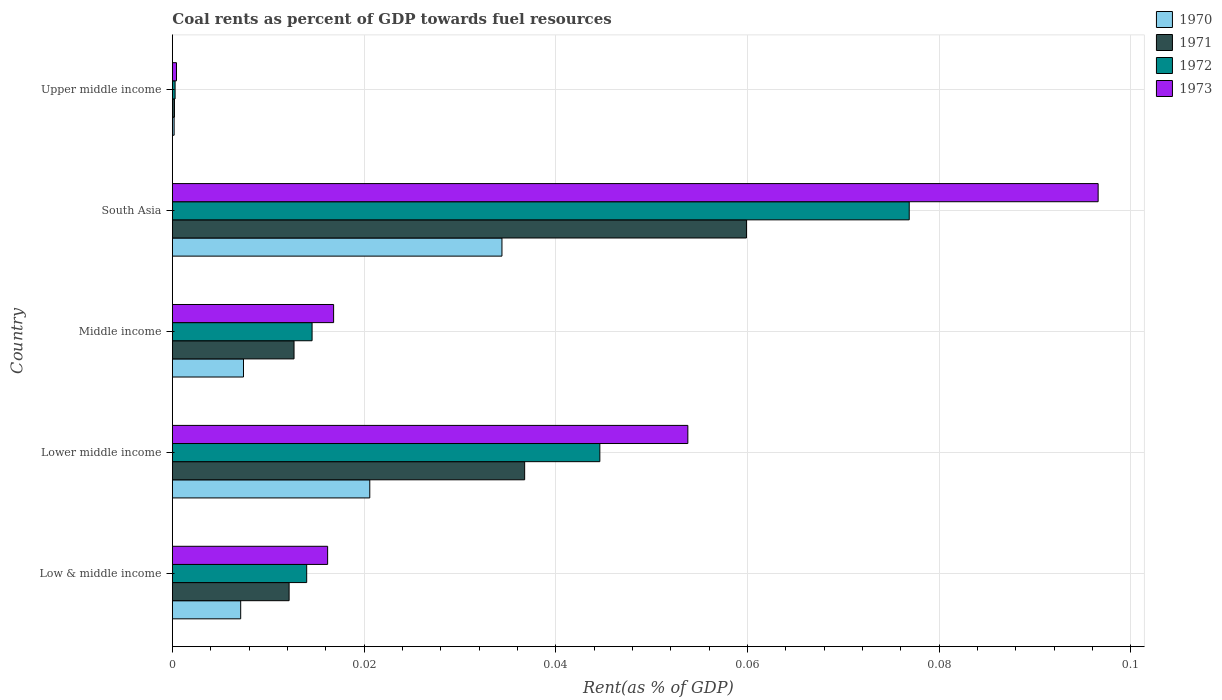How many groups of bars are there?
Your answer should be compact. 5. Are the number of bars on each tick of the Y-axis equal?
Provide a succinct answer. Yes. What is the label of the 5th group of bars from the top?
Provide a succinct answer. Low & middle income. What is the coal rent in 1970 in Upper middle income?
Your answer should be very brief. 0. Across all countries, what is the maximum coal rent in 1970?
Ensure brevity in your answer.  0.03. Across all countries, what is the minimum coal rent in 1970?
Make the answer very short. 0. In which country was the coal rent in 1970 minimum?
Make the answer very short. Upper middle income. What is the total coal rent in 1971 in the graph?
Offer a terse response. 0.12. What is the difference between the coal rent in 1971 in Lower middle income and that in Middle income?
Provide a succinct answer. 0.02. What is the difference between the coal rent in 1971 in South Asia and the coal rent in 1970 in Low & middle income?
Make the answer very short. 0.05. What is the average coal rent in 1970 per country?
Offer a very short reply. 0.01. What is the difference between the coal rent in 1972 and coal rent in 1971 in Low & middle income?
Offer a very short reply. 0. In how many countries, is the coal rent in 1970 greater than 0.044 %?
Ensure brevity in your answer.  0. What is the ratio of the coal rent in 1973 in Lower middle income to that in South Asia?
Give a very brief answer. 0.56. Is the coal rent in 1970 in Lower middle income less than that in Upper middle income?
Your response must be concise. No. What is the difference between the highest and the second highest coal rent in 1971?
Keep it short and to the point. 0.02. What is the difference between the highest and the lowest coal rent in 1973?
Ensure brevity in your answer.  0.1. Is the sum of the coal rent in 1971 in Lower middle income and South Asia greater than the maximum coal rent in 1970 across all countries?
Your answer should be very brief. Yes. Is it the case that in every country, the sum of the coal rent in 1972 and coal rent in 1971 is greater than the sum of coal rent in 1970 and coal rent in 1973?
Your response must be concise. No. What does the 1st bar from the bottom in Upper middle income represents?
Ensure brevity in your answer.  1970. Is it the case that in every country, the sum of the coal rent in 1973 and coal rent in 1971 is greater than the coal rent in 1970?
Provide a short and direct response. Yes. How many bars are there?
Keep it short and to the point. 20. Are all the bars in the graph horizontal?
Your response must be concise. Yes. What is the difference between two consecutive major ticks on the X-axis?
Provide a succinct answer. 0.02. Are the values on the major ticks of X-axis written in scientific E-notation?
Provide a short and direct response. No. What is the title of the graph?
Offer a terse response. Coal rents as percent of GDP towards fuel resources. What is the label or title of the X-axis?
Provide a succinct answer. Rent(as % of GDP). What is the Rent(as % of GDP) in 1970 in Low & middle income?
Keep it short and to the point. 0.01. What is the Rent(as % of GDP) in 1971 in Low & middle income?
Provide a succinct answer. 0.01. What is the Rent(as % of GDP) of 1972 in Low & middle income?
Ensure brevity in your answer.  0.01. What is the Rent(as % of GDP) of 1973 in Low & middle income?
Offer a very short reply. 0.02. What is the Rent(as % of GDP) of 1970 in Lower middle income?
Make the answer very short. 0.02. What is the Rent(as % of GDP) of 1971 in Lower middle income?
Give a very brief answer. 0.04. What is the Rent(as % of GDP) in 1972 in Lower middle income?
Your answer should be very brief. 0.04. What is the Rent(as % of GDP) in 1973 in Lower middle income?
Ensure brevity in your answer.  0.05. What is the Rent(as % of GDP) of 1970 in Middle income?
Your response must be concise. 0.01. What is the Rent(as % of GDP) in 1971 in Middle income?
Give a very brief answer. 0.01. What is the Rent(as % of GDP) of 1972 in Middle income?
Your response must be concise. 0.01. What is the Rent(as % of GDP) of 1973 in Middle income?
Keep it short and to the point. 0.02. What is the Rent(as % of GDP) of 1970 in South Asia?
Make the answer very short. 0.03. What is the Rent(as % of GDP) in 1971 in South Asia?
Your answer should be compact. 0.06. What is the Rent(as % of GDP) of 1972 in South Asia?
Keep it short and to the point. 0.08. What is the Rent(as % of GDP) in 1973 in South Asia?
Provide a short and direct response. 0.1. What is the Rent(as % of GDP) in 1970 in Upper middle income?
Make the answer very short. 0. What is the Rent(as % of GDP) of 1971 in Upper middle income?
Your answer should be compact. 0. What is the Rent(as % of GDP) of 1972 in Upper middle income?
Provide a short and direct response. 0. What is the Rent(as % of GDP) in 1973 in Upper middle income?
Give a very brief answer. 0. Across all countries, what is the maximum Rent(as % of GDP) of 1970?
Make the answer very short. 0.03. Across all countries, what is the maximum Rent(as % of GDP) of 1971?
Keep it short and to the point. 0.06. Across all countries, what is the maximum Rent(as % of GDP) of 1972?
Ensure brevity in your answer.  0.08. Across all countries, what is the maximum Rent(as % of GDP) of 1973?
Offer a very short reply. 0.1. Across all countries, what is the minimum Rent(as % of GDP) of 1970?
Your answer should be very brief. 0. Across all countries, what is the minimum Rent(as % of GDP) in 1971?
Ensure brevity in your answer.  0. Across all countries, what is the minimum Rent(as % of GDP) of 1972?
Your response must be concise. 0. Across all countries, what is the minimum Rent(as % of GDP) of 1973?
Your response must be concise. 0. What is the total Rent(as % of GDP) in 1970 in the graph?
Provide a short and direct response. 0.07. What is the total Rent(as % of GDP) in 1971 in the graph?
Give a very brief answer. 0.12. What is the total Rent(as % of GDP) of 1972 in the graph?
Give a very brief answer. 0.15. What is the total Rent(as % of GDP) of 1973 in the graph?
Ensure brevity in your answer.  0.18. What is the difference between the Rent(as % of GDP) of 1970 in Low & middle income and that in Lower middle income?
Make the answer very short. -0.01. What is the difference between the Rent(as % of GDP) in 1971 in Low & middle income and that in Lower middle income?
Provide a succinct answer. -0.02. What is the difference between the Rent(as % of GDP) in 1972 in Low & middle income and that in Lower middle income?
Provide a succinct answer. -0.03. What is the difference between the Rent(as % of GDP) of 1973 in Low & middle income and that in Lower middle income?
Keep it short and to the point. -0.04. What is the difference between the Rent(as % of GDP) of 1970 in Low & middle income and that in Middle income?
Your answer should be very brief. -0. What is the difference between the Rent(as % of GDP) of 1971 in Low & middle income and that in Middle income?
Offer a terse response. -0. What is the difference between the Rent(as % of GDP) of 1972 in Low & middle income and that in Middle income?
Ensure brevity in your answer.  -0. What is the difference between the Rent(as % of GDP) of 1973 in Low & middle income and that in Middle income?
Your answer should be compact. -0. What is the difference between the Rent(as % of GDP) of 1970 in Low & middle income and that in South Asia?
Ensure brevity in your answer.  -0.03. What is the difference between the Rent(as % of GDP) of 1971 in Low & middle income and that in South Asia?
Your answer should be very brief. -0.05. What is the difference between the Rent(as % of GDP) in 1972 in Low & middle income and that in South Asia?
Keep it short and to the point. -0.06. What is the difference between the Rent(as % of GDP) in 1973 in Low & middle income and that in South Asia?
Ensure brevity in your answer.  -0.08. What is the difference between the Rent(as % of GDP) of 1970 in Low & middle income and that in Upper middle income?
Provide a short and direct response. 0.01. What is the difference between the Rent(as % of GDP) in 1971 in Low & middle income and that in Upper middle income?
Your response must be concise. 0.01. What is the difference between the Rent(as % of GDP) of 1972 in Low & middle income and that in Upper middle income?
Give a very brief answer. 0.01. What is the difference between the Rent(as % of GDP) of 1973 in Low & middle income and that in Upper middle income?
Provide a short and direct response. 0.02. What is the difference between the Rent(as % of GDP) in 1970 in Lower middle income and that in Middle income?
Your response must be concise. 0.01. What is the difference between the Rent(as % of GDP) of 1971 in Lower middle income and that in Middle income?
Your response must be concise. 0.02. What is the difference between the Rent(as % of GDP) of 1972 in Lower middle income and that in Middle income?
Keep it short and to the point. 0.03. What is the difference between the Rent(as % of GDP) of 1973 in Lower middle income and that in Middle income?
Provide a succinct answer. 0.04. What is the difference between the Rent(as % of GDP) of 1970 in Lower middle income and that in South Asia?
Give a very brief answer. -0.01. What is the difference between the Rent(as % of GDP) of 1971 in Lower middle income and that in South Asia?
Make the answer very short. -0.02. What is the difference between the Rent(as % of GDP) of 1972 in Lower middle income and that in South Asia?
Make the answer very short. -0.03. What is the difference between the Rent(as % of GDP) of 1973 in Lower middle income and that in South Asia?
Ensure brevity in your answer.  -0.04. What is the difference between the Rent(as % of GDP) in 1970 in Lower middle income and that in Upper middle income?
Give a very brief answer. 0.02. What is the difference between the Rent(as % of GDP) in 1971 in Lower middle income and that in Upper middle income?
Offer a terse response. 0.04. What is the difference between the Rent(as % of GDP) of 1972 in Lower middle income and that in Upper middle income?
Give a very brief answer. 0.04. What is the difference between the Rent(as % of GDP) in 1973 in Lower middle income and that in Upper middle income?
Offer a very short reply. 0.05. What is the difference between the Rent(as % of GDP) in 1970 in Middle income and that in South Asia?
Ensure brevity in your answer.  -0.03. What is the difference between the Rent(as % of GDP) in 1971 in Middle income and that in South Asia?
Provide a short and direct response. -0.05. What is the difference between the Rent(as % of GDP) of 1972 in Middle income and that in South Asia?
Give a very brief answer. -0.06. What is the difference between the Rent(as % of GDP) in 1973 in Middle income and that in South Asia?
Your answer should be compact. -0.08. What is the difference between the Rent(as % of GDP) of 1970 in Middle income and that in Upper middle income?
Make the answer very short. 0.01. What is the difference between the Rent(as % of GDP) in 1971 in Middle income and that in Upper middle income?
Ensure brevity in your answer.  0.01. What is the difference between the Rent(as % of GDP) in 1972 in Middle income and that in Upper middle income?
Your response must be concise. 0.01. What is the difference between the Rent(as % of GDP) in 1973 in Middle income and that in Upper middle income?
Your response must be concise. 0.02. What is the difference between the Rent(as % of GDP) of 1970 in South Asia and that in Upper middle income?
Provide a short and direct response. 0.03. What is the difference between the Rent(as % of GDP) of 1971 in South Asia and that in Upper middle income?
Make the answer very short. 0.06. What is the difference between the Rent(as % of GDP) in 1972 in South Asia and that in Upper middle income?
Your response must be concise. 0.08. What is the difference between the Rent(as % of GDP) of 1973 in South Asia and that in Upper middle income?
Your answer should be very brief. 0.1. What is the difference between the Rent(as % of GDP) of 1970 in Low & middle income and the Rent(as % of GDP) of 1971 in Lower middle income?
Offer a terse response. -0.03. What is the difference between the Rent(as % of GDP) in 1970 in Low & middle income and the Rent(as % of GDP) in 1972 in Lower middle income?
Your answer should be very brief. -0.04. What is the difference between the Rent(as % of GDP) in 1970 in Low & middle income and the Rent(as % of GDP) in 1973 in Lower middle income?
Keep it short and to the point. -0.05. What is the difference between the Rent(as % of GDP) in 1971 in Low & middle income and the Rent(as % of GDP) in 1972 in Lower middle income?
Your answer should be very brief. -0.03. What is the difference between the Rent(as % of GDP) in 1971 in Low & middle income and the Rent(as % of GDP) in 1973 in Lower middle income?
Offer a terse response. -0.04. What is the difference between the Rent(as % of GDP) in 1972 in Low & middle income and the Rent(as % of GDP) in 1973 in Lower middle income?
Make the answer very short. -0.04. What is the difference between the Rent(as % of GDP) in 1970 in Low & middle income and the Rent(as % of GDP) in 1971 in Middle income?
Give a very brief answer. -0.01. What is the difference between the Rent(as % of GDP) of 1970 in Low & middle income and the Rent(as % of GDP) of 1972 in Middle income?
Your answer should be very brief. -0.01. What is the difference between the Rent(as % of GDP) of 1970 in Low & middle income and the Rent(as % of GDP) of 1973 in Middle income?
Your response must be concise. -0.01. What is the difference between the Rent(as % of GDP) in 1971 in Low & middle income and the Rent(as % of GDP) in 1972 in Middle income?
Ensure brevity in your answer.  -0. What is the difference between the Rent(as % of GDP) in 1971 in Low & middle income and the Rent(as % of GDP) in 1973 in Middle income?
Give a very brief answer. -0. What is the difference between the Rent(as % of GDP) of 1972 in Low & middle income and the Rent(as % of GDP) of 1973 in Middle income?
Offer a very short reply. -0. What is the difference between the Rent(as % of GDP) in 1970 in Low & middle income and the Rent(as % of GDP) in 1971 in South Asia?
Provide a succinct answer. -0.05. What is the difference between the Rent(as % of GDP) of 1970 in Low & middle income and the Rent(as % of GDP) of 1972 in South Asia?
Make the answer very short. -0.07. What is the difference between the Rent(as % of GDP) in 1970 in Low & middle income and the Rent(as % of GDP) in 1973 in South Asia?
Offer a very short reply. -0.09. What is the difference between the Rent(as % of GDP) of 1971 in Low & middle income and the Rent(as % of GDP) of 1972 in South Asia?
Your response must be concise. -0.06. What is the difference between the Rent(as % of GDP) of 1971 in Low & middle income and the Rent(as % of GDP) of 1973 in South Asia?
Your answer should be compact. -0.08. What is the difference between the Rent(as % of GDP) in 1972 in Low & middle income and the Rent(as % of GDP) in 1973 in South Asia?
Your answer should be compact. -0.08. What is the difference between the Rent(as % of GDP) of 1970 in Low & middle income and the Rent(as % of GDP) of 1971 in Upper middle income?
Make the answer very short. 0.01. What is the difference between the Rent(as % of GDP) of 1970 in Low & middle income and the Rent(as % of GDP) of 1972 in Upper middle income?
Make the answer very short. 0.01. What is the difference between the Rent(as % of GDP) in 1970 in Low & middle income and the Rent(as % of GDP) in 1973 in Upper middle income?
Make the answer very short. 0.01. What is the difference between the Rent(as % of GDP) in 1971 in Low & middle income and the Rent(as % of GDP) in 1972 in Upper middle income?
Ensure brevity in your answer.  0.01. What is the difference between the Rent(as % of GDP) of 1971 in Low & middle income and the Rent(as % of GDP) of 1973 in Upper middle income?
Your answer should be very brief. 0.01. What is the difference between the Rent(as % of GDP) of 1972 in Low & middle income and the Rent(as % of GDP) of 1973 in Upper middle income?
Provide a short and direct response. 0.01. What is the difference between the Rent(as % of GDP) in 1970 in Lower middle income and the Rent(as % of GDP) in 1971 in Middle income?
Keep it short and to the point. 0.01. What is the difference between the Rent(as % of GDP) of 1970 in Lower middle income and the Rent(as % of GDP) of 1972 in Middle income?
Keep it short and to the point. 0.01. What is the difference between the Rent(as % of GDP) of 1970 in Lower middle income and the Rent(as % of GDP) of 1973 in Middle income?
Your answer should be very brief. 0. What is the difference between the Rent(as % of GDP) of 1971 in Lower middle income and the Rent(as % of GDP) of 1972 in Middle income?
Ensure brevity in your answer.  0.02. What is the difference between the Rent(as % of GDP) in 1971 in Lower middle income and the Rent(as % of GDP) in 1973 in Middle income?
Your answer should be very brief. 0.02. What is the difference between the Rent(as % of GDP) of 1972 in Lower middle income and the Rent(as % of GDP) of 1973 in Middle income?
Make the answer very short. 0.03. What is the difference between the Rent(as % of GDP) of 1970 in Lower middle income and the Rent(as % of GDP) of 1971 in South Asia?
Ensure brevity in your answer.  -0.04. What is the difference between the Rent(as % of GDP) in 1970 in Lower middle income and the Rent(as % of GDP) in 1972 in South Asia?
Provide a succinct answer. -0.06. What is the difference between the Rent(as % of GDP) of 1970 in Lower middle income and the Rent(as % of GDP) of 1973 in South Asia?
Your answer should be very brief. -0.08. What is the difference between the Rent(as % of GDP) of 1971 in Lower middle income and the Rent(as % of GDP) of 1972 in South Asia?
Your answer should be compact. -0.04. What is the difference between the Rent(as % of GDP) of 1971 in Lower middle income and the Rent(as % of GDP) of 1973 in South Asia?
Make the answer very short. -0.06. What is the difference between the Rent(as % of GDP) in 1972 in Lower middle income and the Rent(as % of GDP) in 1973 in South Asia?
Your answer should be very brief. -0.05. What is the difference between the Rent(as % of GDP) in 1970 in Lower middle income and the Rent(as % of GDP) in 1971 in Upper middle income?
Ensure brevity in your answer.  0.02. What is the difference between the Rent(as % of GDP) in 1970 in Lower middle income and the Rent(as % of GDP) in 1972 in Upper middle income?
Ensure brevity in your answer.  0.02. What is the difference between the Rent(as % of GDP) in 1970 in Lower middle income and the Rent(as % of GDP) in 1973 in Upper middle income?
Offer a very short reply. 0.02. What is the difference between the Rent(as % of GDP) in 1971 in Lower middle income and the Rent(as % of GDP) in 1972 in Upper middle income?
Give a very brief answer. 0.04. What is the difference between the Rent(as % of GDP) in 1971 in Lower middle income and the Rent(as % of GDP) in 1973 in Upper middle income?
Your response must be concise. 0.04. What is the difference between the Rent(as % of GDP) of 1972 in Lower middle income and the Rent(as % of GDP) of 1973 in Upper middle income?
Ensure brevity in your answer.  0.04. What is the difference between the Rent(as % of GDP) of 1970 in Middle income and the Rent(as % of GDP) of 1971 in South Asia?
Offer a very short reply. -0.05. What is the difference between the Rent(as % of GDP) in 1970 in Middle income and the Rent(as % of GDP) in 1972 in South Asia?
Your answer should be very brief. -0.07. What is the difference between the Rent(as % of GDP) in 1970 in Middle income and the Rent(as % of GDP) in 1973 in South Asia?
Offer a very short reply. -0.09. What is the difference between the Rent(as % of GDP) of 1971 in Middle income and the Rent(as % of GDP) of 1972 in South Asia?
Give a very brief answer. -0.06. What is the difference between the Rent(as % of GDP) of 1971 in Middle income and the Rent(as % of GDP) of 1973 in South Asia?
Provide a succinct answer. -0.08. What is the difference between the Rent(as % of GDP) in 1972 in Middle income and the Rent(as % of GDP) in 1973 in South Asia?
Your answer should be compact. -0.08. What is the difference between the Rent(as % of GDP) of 1970 in Middle income and the Rent(as % of GDP) of 1971 in Upper middle income?
Offer a very short reply. 0.01. What is the difference between the Rent(as % of GDP) in 1970 in Middle income and the Rent(as % of GDP) in 1972 in Upper middle income?
Offer a terse response. 0.01. What is the difference between the Rent(as % of GDP) in 1970 in Middle income and the Rent(as % of GDP) in 1973 in Upper middle income?
Make the answer very short. 0.01. What is the difference between the Rent(as % of GDP) of 1971 in Middle income and the Rent(as % of GDP) of 1972 in Upper middle income?
Offer a terse response. 0.01. What is the difference between the Rent(as % of GDP) in 1971 in Middle income and the Rent(as % of GDP) in 1973 in Upper middle income?
Your response must be concise. 0.01. What is the difference between the Rent(as % of GDP) of 1972 in Middle income and the Rent(as % of GDP) of 1973 in Upper middle income?
Your answer should be compact. 0.01. What is the difference between the Rent(as % of GDP) in 1970 in South Asia and the Rent(as % of GDP) in 1971 in Upper middle income?
Your answer should be compact. 0.03. What is the difference between the Rent(as % of GDP) of 1970 in South Asia and the Rent(as % of GDP) of 1972 in Upper middle income?
Provide a short and direct response. 0.03. What is the difference between the Rent(as % of GDP) of 1970 in South Asia and the Rent(as % of GDP) of 1973 in Upper middle income?
Keep it short and to the point. 0.03. What is the difference between the Rent(as % of GDP) of 1971 in South Asia and the Rent(as % of GDP) of 1972 in Upper middle income?
Provide a short and direct response. 0.06. What is the difference between the Rent(as % of GDP) in 1971 in South Asia and the Rent(as % of GDP) in 1973 in Upper middle income?
Offer a very short reply. 0.06. What is the difference between the Rent(as % of GDP) in 1972 in South Asia and the Rent(as % of GDP) in 1973 in Upper middle income?
Ensure brevity in your answer.  0.08. What is the average Rent(as % of GDP) in 1970 per country?
Your answer should be very brief. 0.01. What is the average Rent(as % of GDP) of 1971 per country?
Make the answer very short. 0.02. What is the average Rent(as % of GDP) in 1972 per country?
Provide a succinct answer. 0.03. What is the average Rent(as % of GDP) of 1973 per country?
Your response must be concise. 0.04. What is the difference between the Rent(as % of GDP) of 1970 and Rent(as % of GDP) of 1971 in Low & middle income?
Your answer should be very brief. -0.01. What is the difference between the Rent(as % of GDP) of 1970 and Rent(as % of GDP) of 1972 in Low & middle income?
Ensure brevity in your answer.  -0.01. What is the difference between the Rent(as % of GDP) of 1970 and Rent(as % of GDP) of 1973 in Low & middle income?
Provide a short and direct response. -0.01. What is the difference between the Rent(as % of GDP) in 1971 and Rent(as % of GDP) in 1972 in Low & middle income?
Provide a succinct answer. -0. What is the difference between the Rent(as % of GDP) in 1971 and Rent(as % of GDP) in 1973 in Low & middle income?
Ensure brevity in your answer.  -0. What is the difference between the Rent(as % of GDP) of 1972 and Rent(as % of GDP) of 1973 in Low & middle income?
Your answer should be compact. -0. What is the difference between the Rent(as % of GDP) in 1970 and Rent(as % of GDP) in 1971 in Lower middle income?
Keep it short and to the point. -0.02. What is the difference between the Rent(as % of GDP) of 1970 and Rent(as % of GDP) of 1972 in Lower middle income?
Give a very brief answer. -0.02. What is the difference between the Rent(as % of GDP) of 1970 and Rent(as % of GDP) of 1973 in Lower middle income?
Your response must be concise. -0.03. What is the difference between the Rent(as % of GDP) in 1971 and Rent(as % of GDP) in 1972 in Lower middle income?
Provide a short and direct response. -0.01. What is the difference between the Rent(as % of GDP) of 1971 and Rent(as % of GDP) of 1973 in Lower middle income?
Give a very brief answer. -0.02. What is the difference between the Rent(as % of GDP) in 1972 and Rent(as % of GDP) in 1973 in Lower middle income?
Your answer should be very brief. -0.01. What is the difference between the Rent(as % of GDP) of 1970 and Rent(as % of GDP) of 1971 in Middle income?
Make the answer very short. -0.01. What is the difference between the Rent(as % of GDP) of 1970 and Rent(as % of GDP) of 1972 in Middle income?
Provide a short and direct response. -0.01. What is the difference between the Rent(as % of GDP) of 1970 and Rent(as % of GDP) of 1973 in Middle income?
Your answer should be very brief. -0.01. What is the difference between the Rent(as % of GDP) of 1971 and Rent(as % of GDP) of 1972 in Middle income?
Offer a terse response. -0. What is the difference between the Rent(as % of GDP) in 1971 and Rent(as % of GDP) in 1973 in Middle income?
Make the answer very short. -0. What is the difference between the Rent(as % of GDP) of 1972 and Rent(as % of GDP) of 1973 in Middle income?
Provide a short and direct response. -0. What is the difference between the Rent(as % of GDP) of 1970 and Rent(as % of GDP) of 1971 in South Asia?
Provide a short and direct response. -0.03. What is the difference between the Rent(as % of GDP) in 1970 and Rent(as % of GDP) in 1972 in South Asia?
Provide a short and direct response. -0.04. What is the difference between the Rent(as % of GDP) of 1970 and Rent(as % of GDP) of 1973 in South Asia?
Offer a very short reply. -0.06. What is the difference between the Rent(as % of GDP) of 1971 and Rent(as % of GDP) of 1972 in South Asia?
Your response must be concise. -0.02. What is the difference between the Rent(as % of GDP) in 1971 and Rent(as % of GDP) in 1973 in South Asia?
Give a very brief answer. -0.04. What is the difference between the Rent(as % of GDP) in 1972 and Rent(as % of GDP) in 1973 in South Asia?
Provide a succinct answer. -0.02. What is the difference between the Rent(as % of GDP) of 1970 and Rent(as % of GDP) of 1971 in Upper middle income?
Your answer should be compact. -0. What is the difference between the Rent(as % of GDP) of 1970 and Rent(as % of GDP) of 1972 in Upper middle income?
Offer a very short reply. -0. What is the difference between the Rent(as % of GDP) in 1970 and Rent(as % of GDP) in 1973 in Upper middle income?
Provide a succinct answer. -0. What is the difference between the Rent(as % of GDP) in 1971 and Rent(as % of GDP) in 1972 in Upper middle income?
Offer a terse response. -0. What is the difference between the Rent(as % of GDP) in 1971 and Rent(as % of GDP) in 1973 in Upper middle income?
Offer a terse response. -0. What is the difference between the Rent(as % of GDP) of 1972 and Rent(as % of GDP) of 1973 in Upper middle income?
Offer a terse response. -0. What is the ratio of the Rent(as % of GDP) in 1970 in Low & middle income to that in Lower middle income?
Ensure brevity in your answer.  0.35. What is the ratio of the Rent(as % of GDP) of 1971 in Low & middle income to that in Lower middle income?
Give a very brief answer. 0.33. What is the ratio of the Rent(as % of GDP) of 1972 in Low & middle income to that in Lower middle income?
Make the answer very short. 0.31. What is the ratio of the Rent(as % of GDP) of 1973 in Low & middle income to that in Lower middle income?
Offer a terse response. 0.3. What is the ratio of the Rent(as % of GDP) in 1970 in Low & middle income to that in Middle income?
Provide a succinct answer. 0.96. What is the ratio of the Rent(as % of GDP) of 1971 in Low & middle income to that in Middle income?
Offer a very short reply. 0.96. What is the ratio of the Rent(as % of GDP) of 1972 in Low & middle income to that in Middle income?
Give a very brief answer. 0.96. What is the ratio of the Rent(as % of GDP) of 1973 in Low & middle income to that in Middle income?
Offer a terse response. 0.96. What is the ratio of the Rent(as % of GDP) in 1970 in Low & middle income to that in South Asia?
Offer a very short reply. 0.21. What is the ratio of the Rent(as % of GDP) of 1971 in Low & middle income to that in South Asia?
Provide a succinct answer. 0.2. What is the ratio of the Rent(as % of GDP) in 1972 in Low & middle income to that in South Asia?
Provide a short and direct response. 0.18. What is the ratio of the Rent(as % of GDP) in 1973 in Low & middle income to that in South Asia?
Your response must be concise. 0.17. What is the ratio of the Rent(as % of GDP) of 1970 in Low & middle income to that in Upper middle income?
Your answer should be compact. 38.77. What is the ratio of the Rent(as % of GDP) of 1971 in Low & middle income to that in Upper middle income?
Your response must be concise. 55.66. What is the ratio of the Rent(as % of GDP) of 1972 in Low & middle income to that in Upper middle income?
Keep it short and to the point. 49.28. What is the ratio of the Rent(as % of GDP) of 1973 in Low & middle income to that in Upper middle income?
Offer a terse response. 37.59. What is the ratio of the Rent(as % of GDP) of 1970 in Lower middle income to that in Middle income?
Keep it short and to the point. 2.78. What is the ratio of the Rent(as % of GDP) of 1971 in Lower middle income to that in Middle income?
Provide a succinct answer. 2.9. What is the ratio of the Rent(as % of GDP) in 1972 in Lower middle income to that in Middle income?
Your response must be concise. 3.06. What is the ratio of the Rent(as % of GDP) in 1973 in Lower middle income to that in Middle income?
Your answer should be compact. 3.2. What is the ratio of the Rent(as % of GDP) in 1970 in Lower middle income to that in South Asia?
Your answer should be compact. 0.6. What is the ratio of the Rent(as % of GDP) of 1971 in Lower middle income to that in South Asia?
Ensure brevity in your answer.  0.61. What is the ratio of the Rent(as % of GDP) in 1972 in Lower middle income to that in South Asia?
Ensure brevity in your answer.  0.58. What is the ratio of the Rent(as % of GDP) in 1973 in Lower middle income to that in South Asia?
Offer a terse response. 0.56. What is the ratio of the Rent(as % of GDP) of 1970 in Lower middle income to that in Upper middle income?
Give a very brief answer. 112.03. What is the ratio of the Rent(as % of GDP) in 1971 in Lower middle income to that in Upper middle income?
Ensure brevity in your answer.  167.98. What is the ratio of the Rent(as % of GDP) of 1972 in Lower middle income to that in Upper middle income?
Ensure brevity in your answer.  156.82. What is the ratio of the Rent(as % of GDP) of 1973 in Lower middle income to that in Upper middle income?
Your response must be concise. 124.82. What is the ratio of the Rent(as % of GDP) of 1970 in Middle income to that in South Asia?
Your response must be concise. 0.22. What is the ratio of the Rent(as % of GDP) of 1971 in Middle income to that in South Asia?
Offer a terse response. 0.21. What is the ratio of the Rent(as % of GDP) of 1972 in Middle income to that in South Asia?
Ensure brevity in your answer.  0.19. What is the ratio of the Rent(as % of GDP) in 1973 in Middle income to that in South Asia?
Give a very brief answer. 0.17. What is the ratio of the Rent(as % of GDP) in 1970 in Middle income to that in Upper middle income?
Offer a terse response. 40.36. What is the ratio of the Rent(as % of GDP) of 1971 in Middle income to that in Upper middle income?
Make the answer very short. 58.01. What is the ratio of the Rent(as % of GDP) of 1972 in Middle income to that in Upper middle income?
Your answer should be compact. 51.25. What is the ratio of the Rent(as % of GDP) of 1973 in Middle income to that in Upper middle income?
Offer a terse response. 39.04. What is the ratio of the Rent(as % of GDP) in 1970 in South Asia to that in Upper middle income?
Your answer should be compact. 187.05. What is the ratio of the Rent(as % of GDP) in 1971 in South Asia to that in Upper middle income?
Give a very brief answer. 273.74. What is the ratio of the Rent(as % of GDP) in 1972 in South Asia to that in Upper middle income?
Provide a short and direct response. 270.32. What is the ratio of the Rent(as % of GDP) in 1973 in South Asia to that in Upper middle income?
Give a very brief answer. 224.18. What is the difference between the highest and the second highest Rent(as % of GDP) in 1970?
Offer a very short reply. 0.01. What is the difference between the highest and the second highest Rent(as % of GDP) of 1971?
Ensure brevity in your answer.  0.02. What is the difference between the highest and the second highest Rent(as % of GDP) of 1972?
Your response must be concise. 0.03. What is the difference between the highest and the second highest Rent(as % of GDP) in 1973?
Your response must be concise. 0.04. What is the difference between the highest and the lowest Rent(as % of GDP) of 1970?
Ensure brevity in your answer.  0.03. What is the difference between the highest and the lowest Rent(as % of GDP) in 1971?
Keep it short and to the point. 0.06. What is the difference between the highest and the lowest Rent(as % of GDP) in 1972?
Ensure brevity in your answer.  0.08. What is the difference between the highest and the lowest Rent(as % of GDP) of 1973?
Keep it short and to the point. 0.1. 